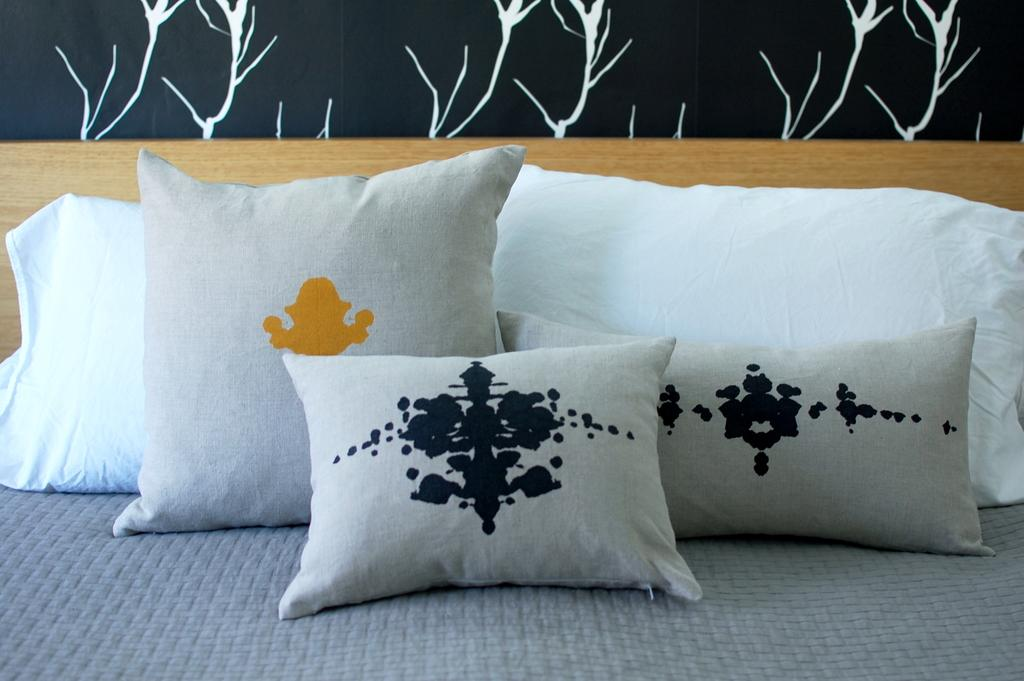What objects are placed on the cloth in the image? There are pillows on a cloth in the image. What type of material is the wooden object made of in the background? The wooden object in the background is made of wood. What can be seen on the wall in the background of the image? There is a painting on the wall in the background of the image. What type of chalk is being used to draw the plot in the image? There is no chalk or plot present in the image. 